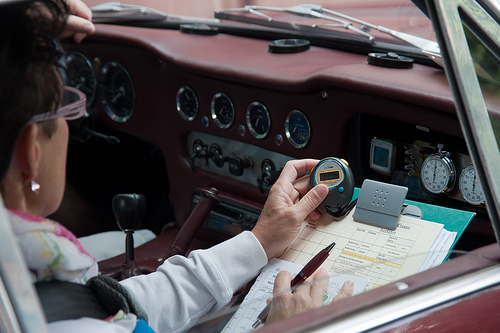Please provide a short description for this region: [0.38, 0.56, 0.51, 0.63]. The specified area shows a vintage vehicle's radio, likely from the mid to late 20th century, featuring classic analog dials and buttons. 